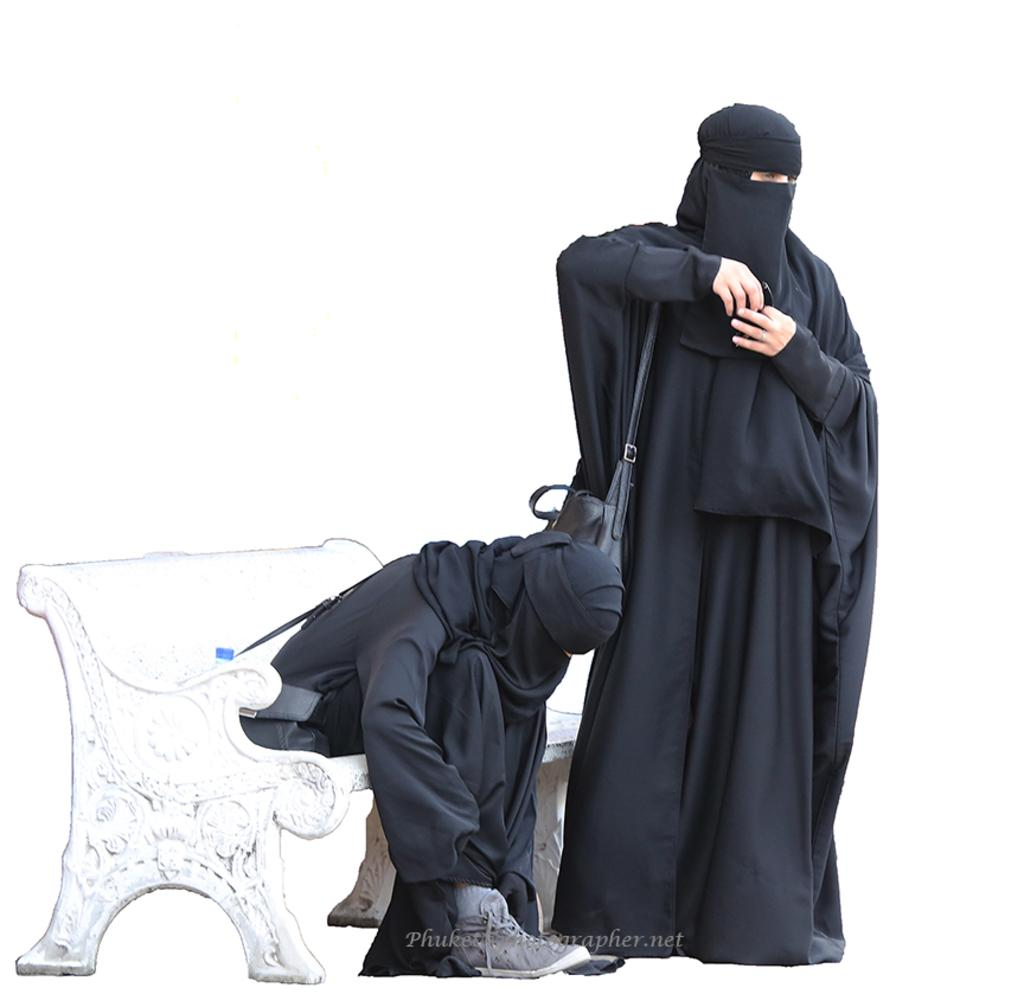How many women are in the image? There are two women in the image. What are the women wearing? Both women are wearing abayas. What is the position of the woman on the right side? The woman on the right side is standing. What is the woman on the right side holding? The woman on the right side is holding a bag. What is the position of the woman on the left side? The woman on the left side is sitting on a table. What type of quartz can be seen in the image? There is no quartz present in the image. What is the name of the woman on the left side? The provided facts do not include the names of the women in the image. 